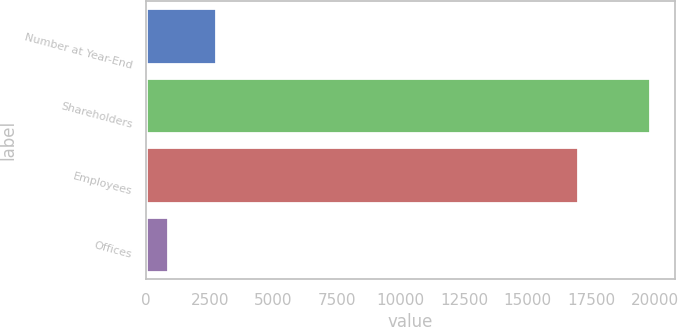Convert chart. <chart><loc_0><loc_0><loc_500><loc_500><bar_chart><fcel>Number at Year-End<fcel>Shareholders<fcel>Employees<fcel>Offices<nl><fcel>2749.7<fcel>19802<fcel>16973<fcel>855<nl></chart> 